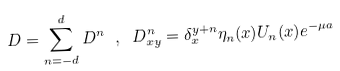Convert formula to latex. <formula><loc_0><loc_0><loc_500><loc_500>D = \sum _ { n = - d } ^ { d } D ^ { n } \ , \ D ^ { n } _ { x y } = \delta _ { x } ^ { y + n } \eta _ { n } ( x ) U _ { n } ( x ) e ^ { - \mu a }</formula> 